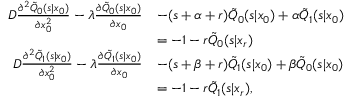<formula> <loc_0><loc_0><loc_500><loc_500>\begin{array} { r l } { D \frac { \partial ^ { 2 } \tilde { Q } _ { 0 } ( s | x _ { 0 } ) } { \partial x _ { 0 } ^ { 2 } } - \lambda \frac { \partial \tilde { Q } _ { 0 } ( s | x _ { 0 } ) } { \partial x _ { 0 } } } & { - ( s + \alpha + r ) \tilde { Q } _ { 0 } ( s | x _ { 0 } ) + \alpha \tilde { Q } _ { 1 } ( s | x _ { 0 } ) } \\ & { = - 1 - r \tilde { Q } _ { 0 } ( s | x _ { r } ) } \\ { D \frac { \partial ^ { 2 } \tilde { Q } _ { 1 } ( s | x _ { 0 } ) } { \partial x _ { 0 } ^ { 2 } } - \lambda \frac { \partial \tilde { Q } _ { 1 } ( s | x _ { 0 } ) } { \partial x _ { 0 } } } & { - ( s + \beta + r ) \tilde { Q } _ { 1 } ( s | x _ { 0 } ) + \beta \tilde { Q } _ { 0 } ( s | x _ { 0 } ) } \\ & { = - 1 - r \tilde { Q } _ { 1 } ( s | x _ { r } ) , } \end{array}</formula> 